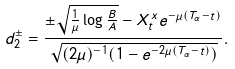Convert formula to latex. <formula><loc_0><loc_0><loc_500><loc_500>d _ { 2 } ^ { \pm } = \frac { \pm \sqrt { \frac { 1 } { \mu } \log \frac { B } { A } } - X ^ { x } _ { t } e ^ { - \mu ( T _ { \alpha } - t ) } } { \sqrt { ( 2 \mu ) ^ { - 1 } ( 1 - e ^ { - 2 \mu ( T _ { \alpha } - t ) } ) } } .</formula> 